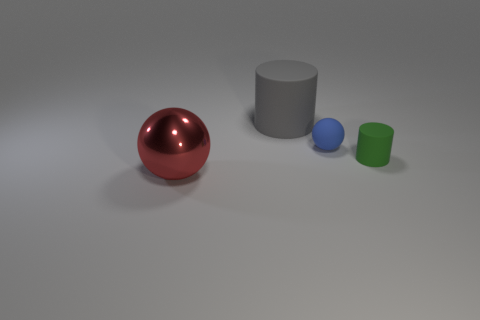Is there anything else that is the same material as the red ball?
Provide a succinct answer. No. Is the number of big blue matte spheres greater than the number of tiny green rubber things?
Make the answer very short. No. There is a green object that is the same material as the blue ball; what size is it?
Your answer should be compact. Small. Does the sphere that is on the right side of the red object have the same size as the sphere in front of the small ball?
Your answer should be compact. No. What number of objects are either green matte cylinders to the right of the red shiny ball or gray matte spheres?
Make the answer very short. 1. Are there fewer small purple matte cylinders than gray objects?
Give a very brief answer. Yes. There is a tiny green thing right of the cylinder behind the cylinder that is in front of the large matte cylinder; what is its shape?
Ensure brevity in your answer.  Cylinder. Are any large rubber cylinders visible?
Offer a very short reply. Yes. Does the blue sphere have the same size as the thing that is behind the tiny matte sphere?
Your answer should be very brief. No. Are there any big things that are on the right side of the rubber thing that is behind the tiny ball?
Offer a very short reply. No. 